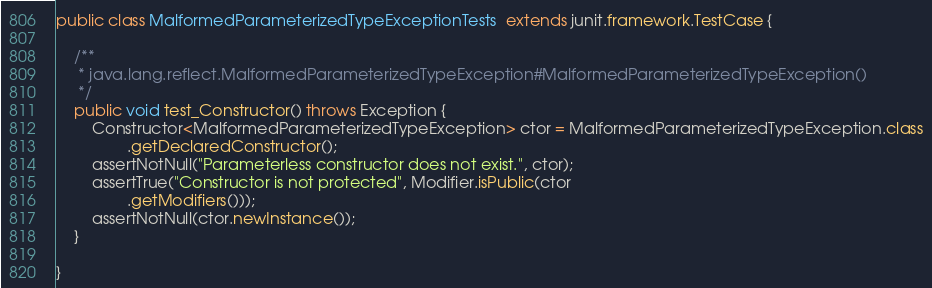<code> <loc_0><loc_0><loc_500><loc_500><_Java_>
public class MalformedParameterizedTypeExceptionTests  extends junit.framework.TestCase {

    /**
     * java.lang.reflect.MalformedParameterizedTypeException#MalformedParameterizedTypeException()
     */
    public void test_Constructor() throws Exception {
        Constructor<MalformedParameterizedTypeException> ctor = MalformedParameterizedTypeException.class
                .getDeclaredConstructor();
        assertNotNull("Parameterless constructor does not exist.", ctor);
        assertTrue("Constructor is not protected", Modifier.isPublic(ctor
                .getModifiers()));
        assertNotNull(ctor.newInstance());
    }

}
</code> 